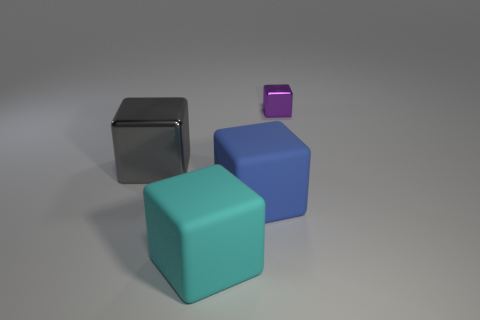There is a large cube that is in front of the gray metal thing and behind the large cyan thing; what is its color?
Your answer should be very brief. Blue. Is the number of cubes behind the tiny purple shiny cube less than the number of cyan things in front of the cyan rubber block?
Provide a short and direct response. No. What number of tiny yellow matte objects are the same shape as the tiny metal thing?
Offer a terse response. 0. There is a thing that is the same material as the blue block; what size is it?
Provide a succinct answer. Large. There is a metallic thing to the left of the matte block to the right of the big cyan block; what color is it?
Provide a succinct answer. Gray. There is a purple thing; is it the same shape as the rubber object left of the large blue rubber thing?
Your answer should be very brief. Yes. How many gray objects have the same size as the purple object?
Your answer should be very brief. 0. What material is the cyan object that is the same shape as the blue rubber thing?
Keep it short and to the point. Rubber. Do the block that is right of the blue block and the object in front of the large blue matte thing have the same color?
Your answer should be compact. No. What shape is the big object that is behind the big blue block?
Your answer should be compact. Cube. 